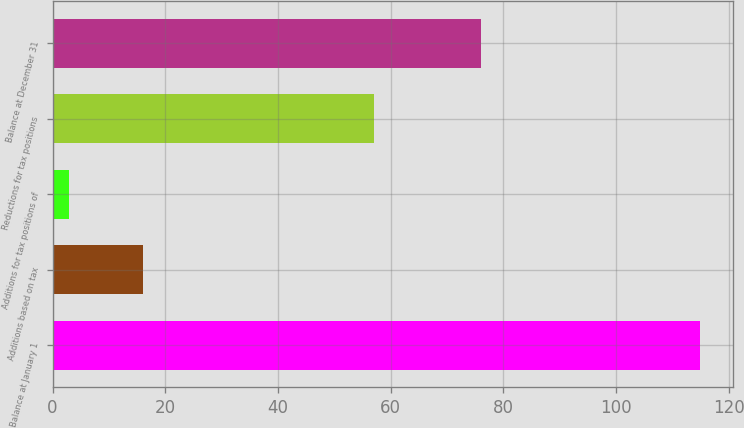Convert chart. <chart><loc_0><loc_0><loc_500><loc_500><bar_chart><fcel>Balance at January 1<fcel>Additions based on tax<fcel>Additions for tax positions of<fcel>Reductions for tax positions<fcel>Balance at December 31<nl><fcel>115<fcel>16<fcel>3<fcel>57<fcel>76<nl></chart> 